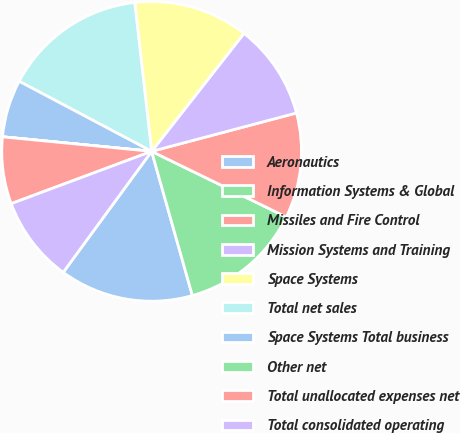<chart> <loc_0><loc_0><loc_500><loc_500><pie_chart><fcel>Aeronautics<fcel>Information Systems & Global<fcel>Missiles and Fire Control<fcel>Mission Systems and Training<fcel>Space Systems<fcel>Total net sales<fcel>Space Systems Total business<fcel>Other net<fcel>Total unallocated expenses net<fcel>Total consolidated operating<nl><fcel>14.43%<fcel>13.4%<fcel>11.34%<fcel>10.31%<fcel>12.37%<fcel>15.46%<fcel>6.19%<fcel>0.01%<fcel>7.22%<fcel>9.28%<nl></chart> 